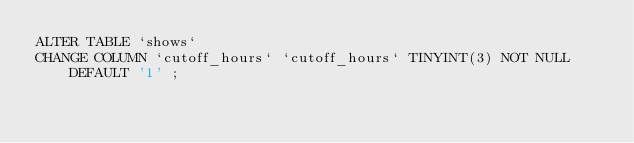<code> <loc_0><loc_0><loc_500><loc_500><_SQL_>ALTER TABLE `shows` 
CHANGE COLUMN `cutoff_hours` `cutoff_hours` TINYINT(3) NOT NULL DEFAULT '1' ;</code> 